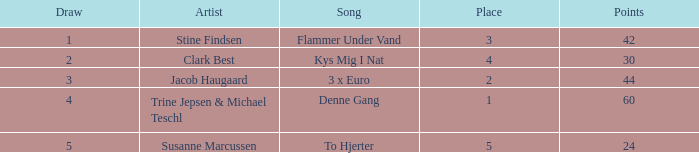What is the lowest Draw when the Artist is Stine Findsen and the Points are larger than 42? None. 